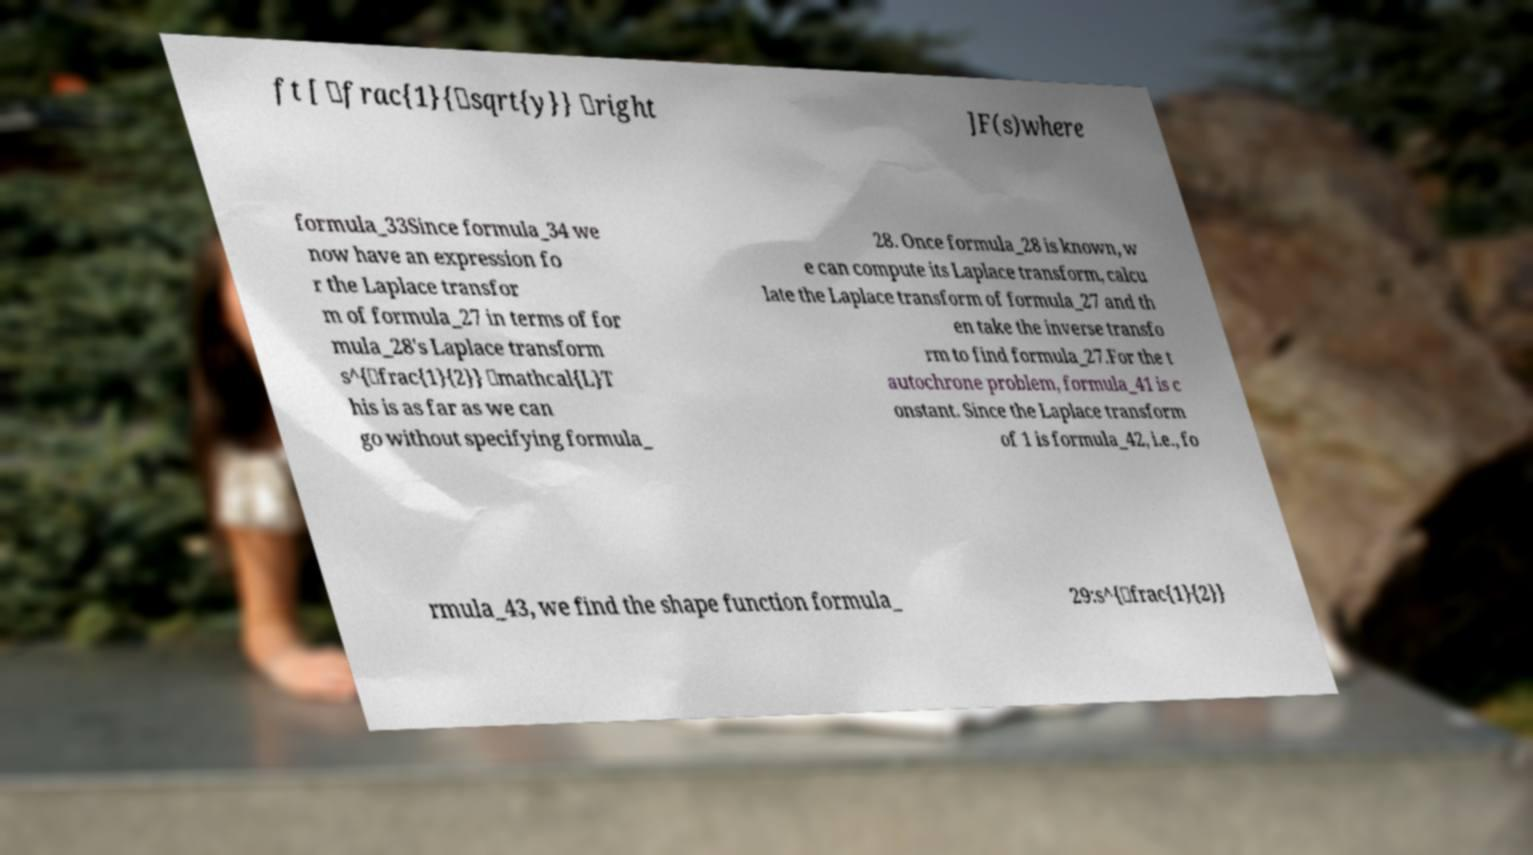What messages or text are displayed in this image? I need them in a readable, typed format. ft [ \frac{1}{\sqrt{y}} \right ]F(s)where formula_33Since formula_34 we now have an expression fo r the Laplace transfor m of formula_27 in terms of for mula_28's Laplace transform s^{\frac{1}{2}} \mathcal{L}T his is as far as we can go without specifying formula_ 28. Once formula_28 is known, w e can compute its Laplace transform, calcu late the Laplace transform of formula_27 and th en take the inverse transfo rm to find formula_27.For the t autochrone problem, formula_41 is c onstant. Since the Laplace transform of 1 is formula_42, i.e., fo rmula_43, we find the shape function formula_ 29:s^{\frac{1}{2}} 